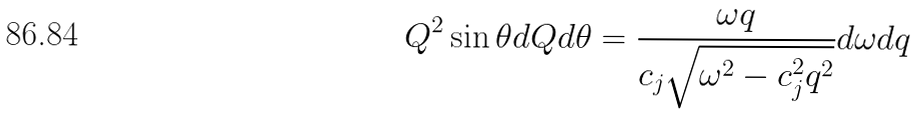Convert formula to latex. <formula><loc_0><loc_0><loc_500><loc_500>Q ^ { 2 } \sin \theta d Q d \theta = \frac { \omega q } { c _ { j } \sqrt { \omega ^ { 2 } - c _ { j } ^ { 2 } q ^ { 2 } } } d \omega d q</formula> 